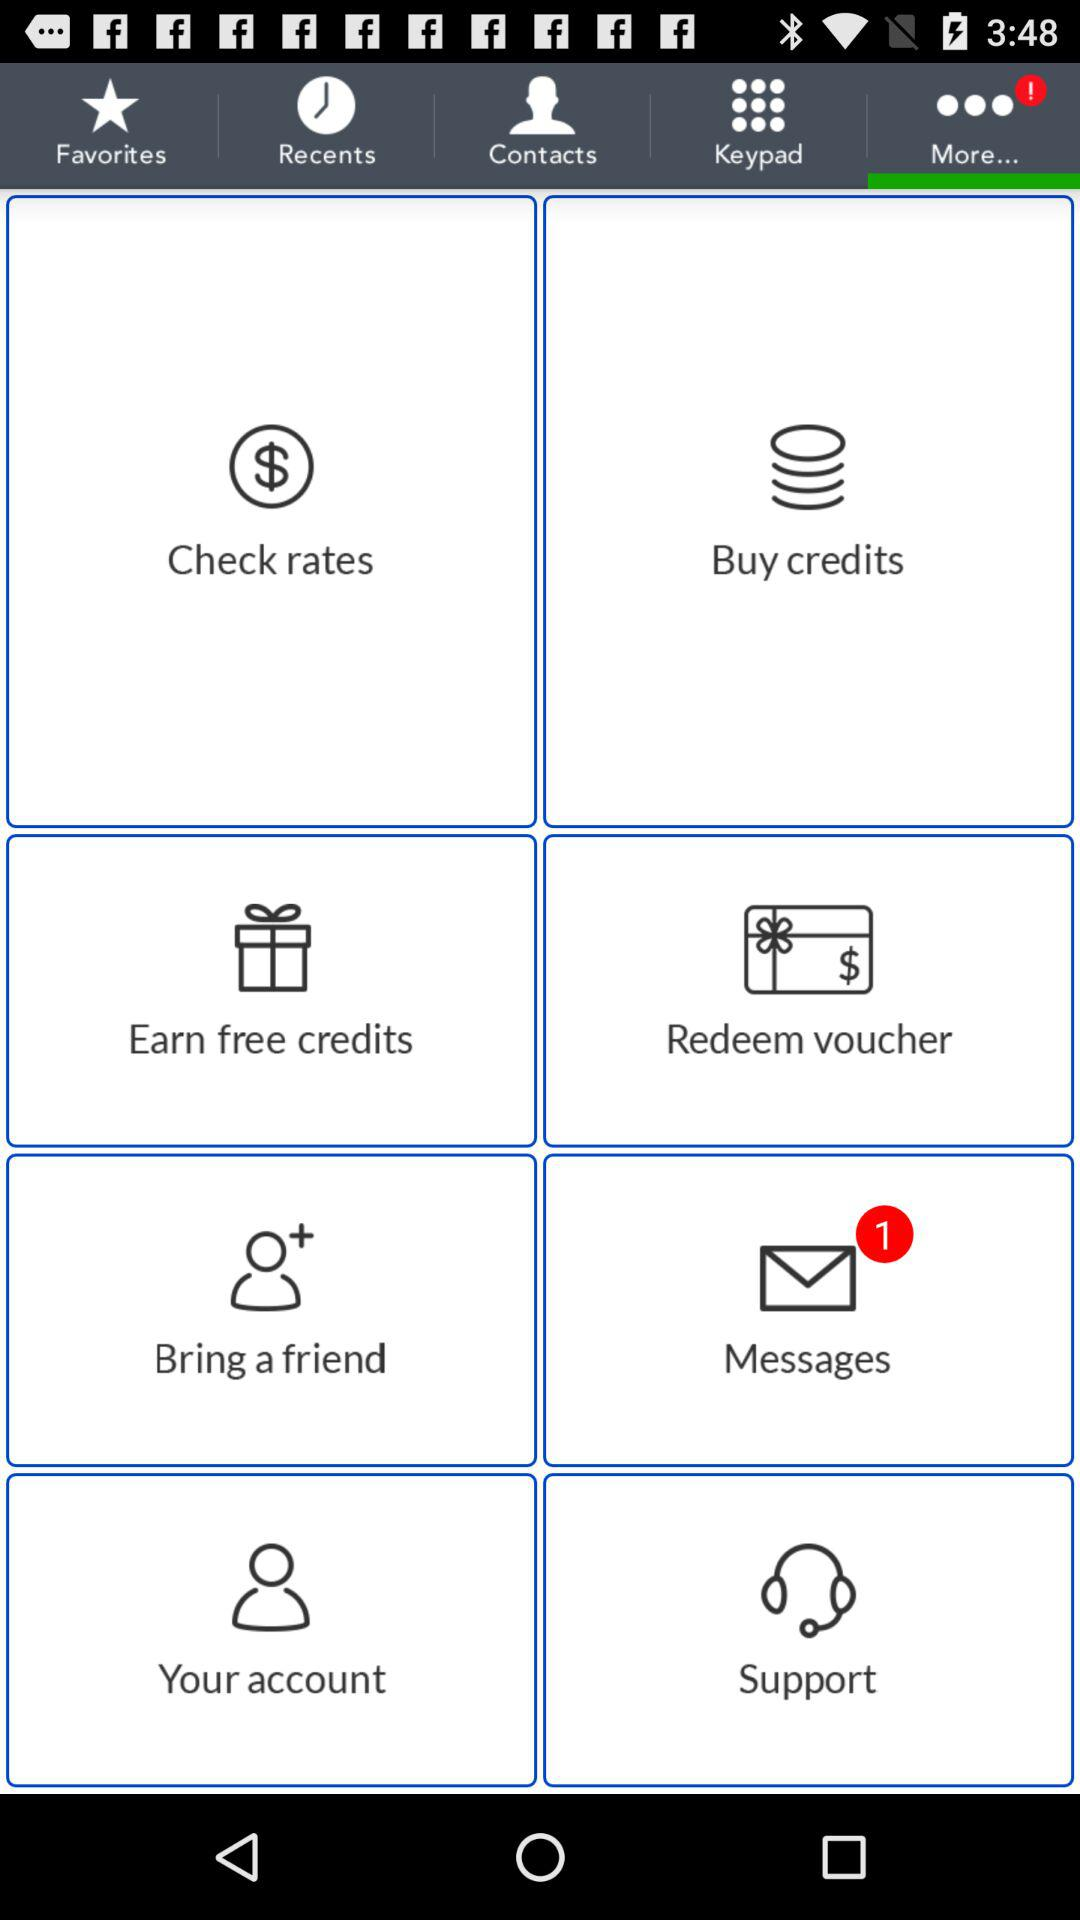How many unread messages are there? There is 1 unread message. 